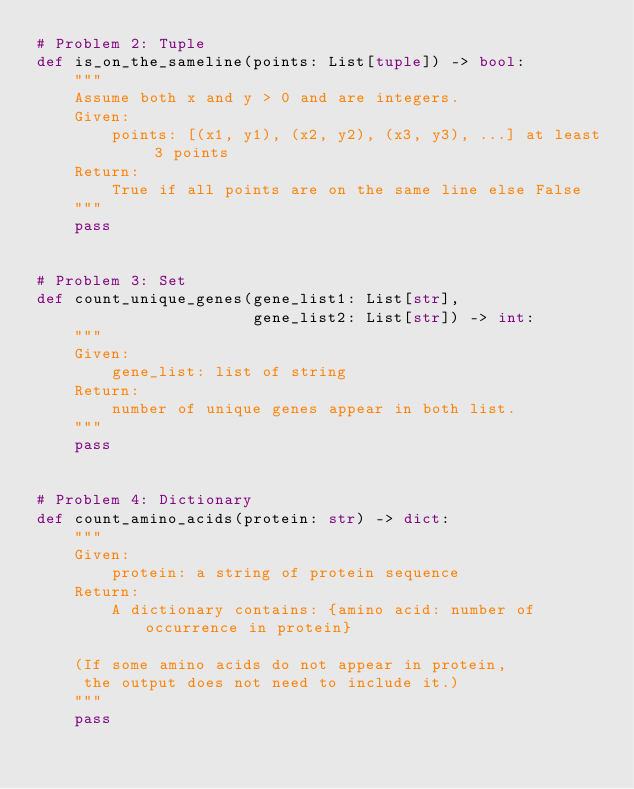Convert code to text. <code><loc_0><loc_0><loc_500><loc_500><_Python_># Problem 2: Tuple
def is_on_the_sameline(points: List[tuple]) -> bool:
    """
    Assume both x and y > 0 and are integers.
    Given:
        points: [(x1, y1), (x2, y2), (x3, y3), ...] at least 3 points
    Return:
        True if all points are on the same line else False
    """
    pass
    

# Problem 3: Set
def count_unique_genes(gene_list1: List[str], 
                       gene_list2: List[str]) -> int:
    """
    Given:
        gene_list: list of string
    Return:
        number of unique genes appear in both list.
    """
    pass


# Problem 4: Dictionary
def count_amino_acids(protein: str) -> dict:
    """
    Given:
        protein: a string of protein sequence
    Return:
        A dictionary contains: {amino acid: number of occurrence in protein}
    
    (If some amino acids do not appear in protein, 
     the output does not need to include it.)
    """
    pass

</code> 